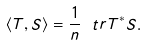Convert formula to latex. <formula><loc_0><loc_0><loc_500><loc_500>\langle T , S \rangle = \frac { 1 } { n } \ t r { T ^ { * } S } .</formula> 